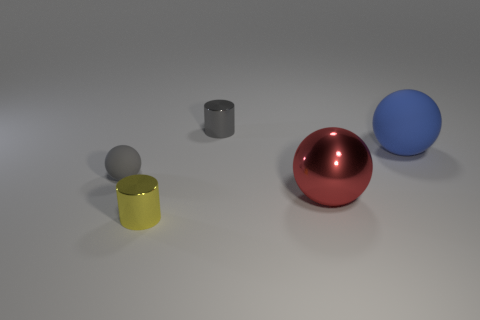There is a yellow metallic cylinder; are there any matte objects to the right of it?
Provide a succinct answer. Yes. There is a gray thing that is the same material as the large blue thing; what is its size?
Ensure brevity in your answer.  Small. How many metallic cylinders have the same color as the small sphere?
Your answer should be very brief. 1. Are there fewer small gray objects that are in front of the small gray cylinder than metal objects left of the red metallic ball?
Your answer should be compact. Yes. What is the size of the shiny object that is to the right of the small gray metal object?
Ensure brevity in your answer.  Large. Is there a small yellow cylinder that has the same material as the small gray cylinder?
Give a very brief answer. Yes. Is the material of the small yellow cylinder the same as the large blue thing?
Keep it short and to the point. No. There is a rubber thing that is the same size as the red metallic object; what is its color?
Provide a succinct answer. Blue. How many other things are the same shape as the gray metal thing?
Your answer should be compact. 1. There is a gray metal cylinder; is its size the same as the red object that is left of the blue rubber thing?
Your answer should be compact. No. 